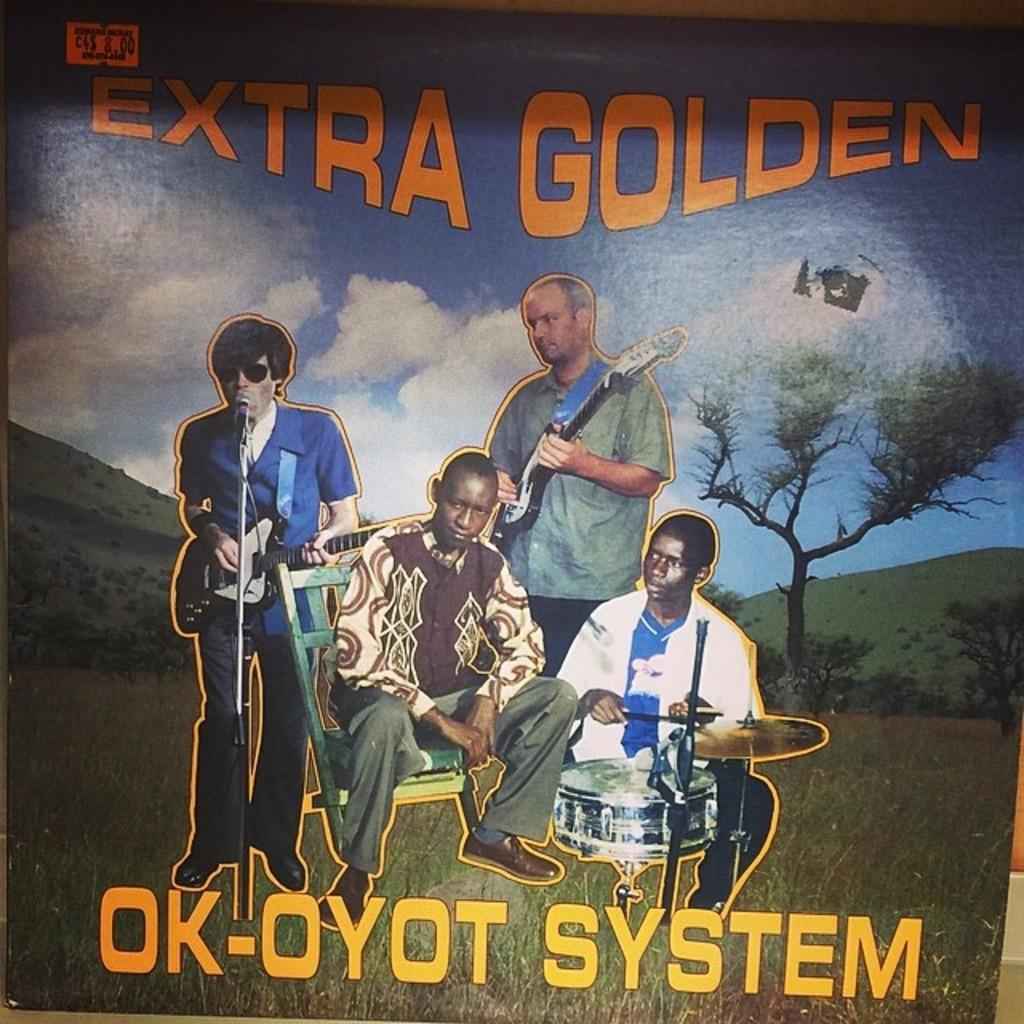<image>
Describe the image concisely. A vinyl record showing a band says Extra Golden Ok-Oyot System. 